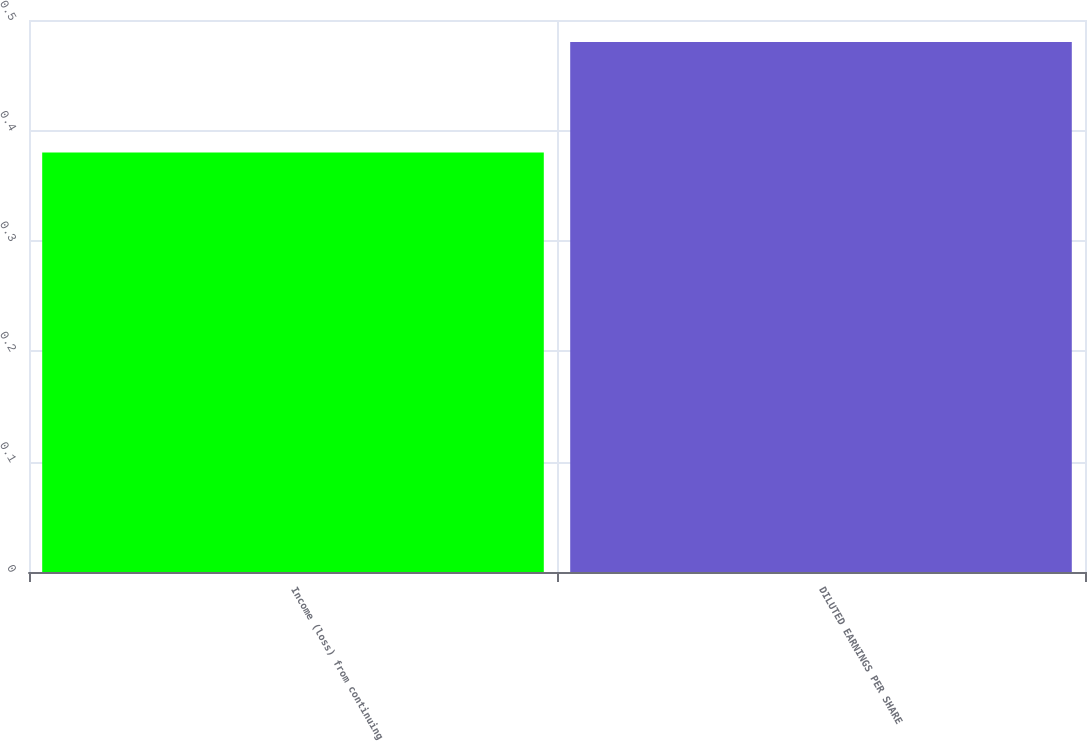Convert chart to OTSL. <chart><loc_0><loc_0><loc_500><loc_500><bar_chart><fcel>Income (loss) from continuing<fcel>DILUTED EARNINGS PER SHARE<nl><fcel>0.38<fcel>0.48<nl></chart> 